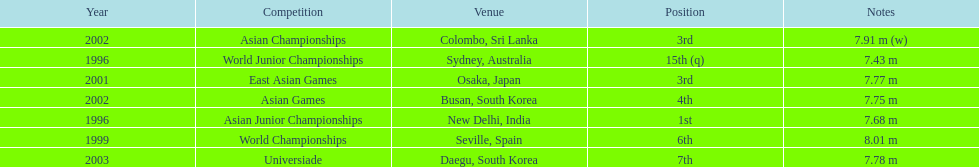What was the only competition where this competitor achieved 1st place? Asian Junior Championships. 